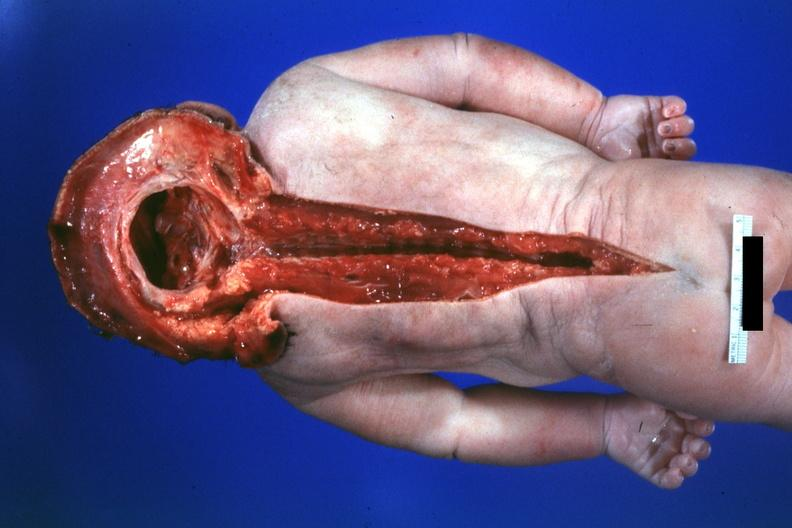what is no chromosomal defects lived?
Answer the question using a single word or phrase. One day 